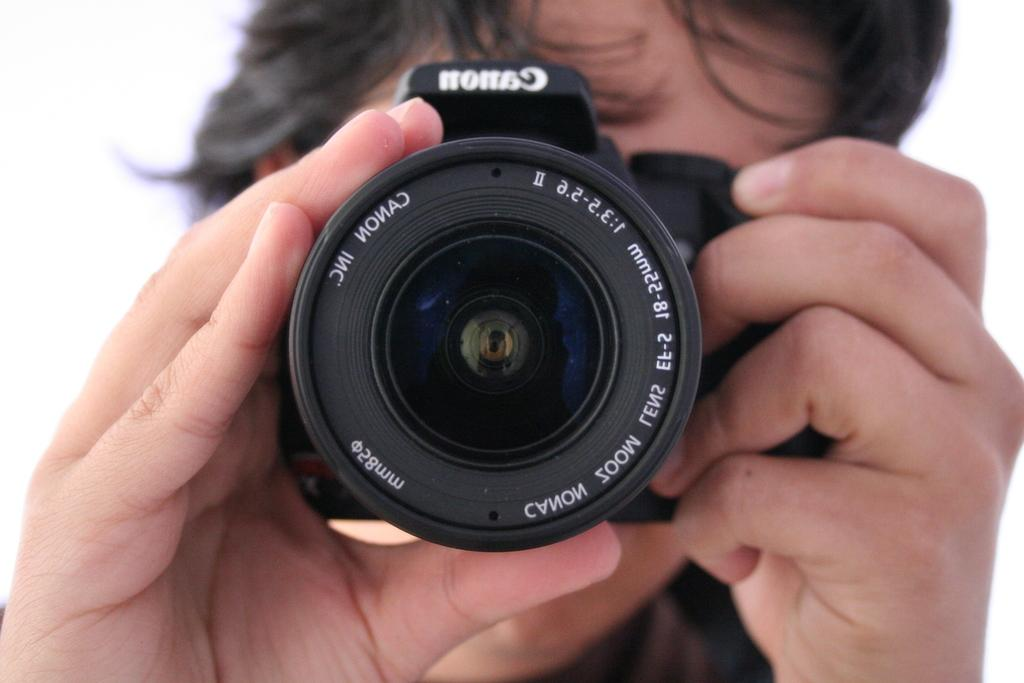Provide a one-sentence caption for the provided image. A person holding a Canon Inc. camera pointing the lens. 